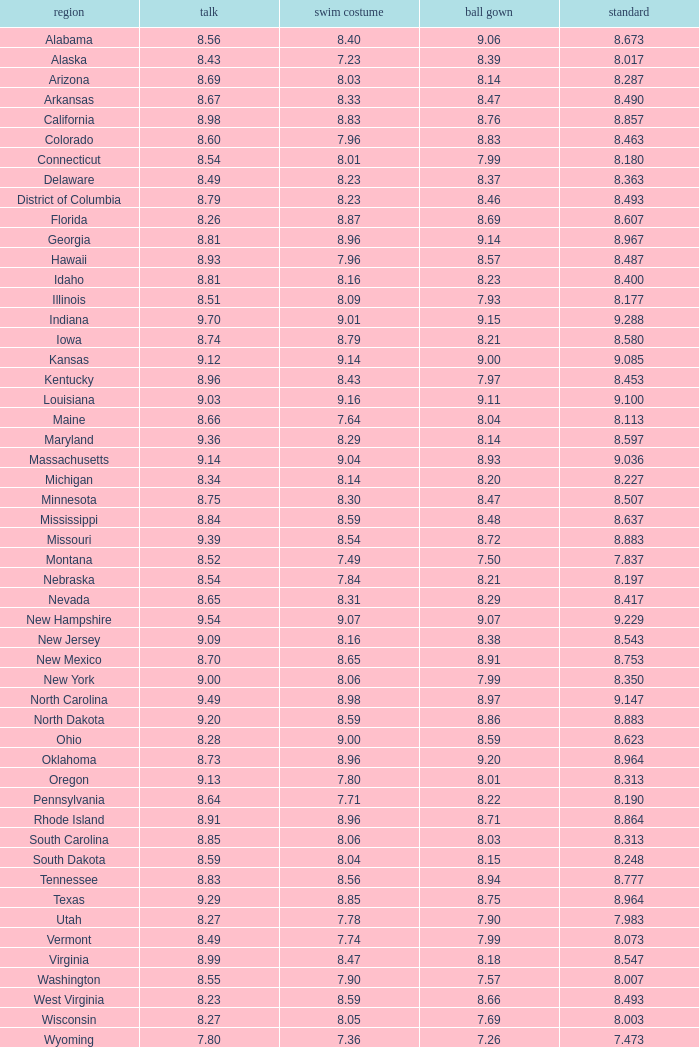Name the state with an evening gown more than 8.86 and interview less than 8.7 and swimsuit less than 8.96 Alabama. 